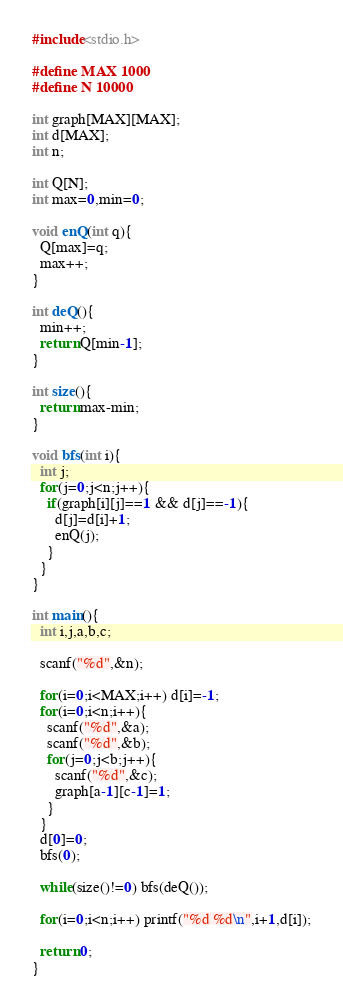<code> <loc_0><loc_0><loc_500><loc_500><_C_>#include<stdio.h>

#define MAX 1000
#define N 10000

int graph[MAX][MAX];
int d[MAX];
int n;

int Q[N];
int max=0,min=0;

void enQ(int q){
  Q[max]=q;
  max++;
}

int deQ(){
  min++;
  return Q[min-1];
}

int size(){
  return max-min;
}

void bfs(int i){
  int j;
  for(j=0;j<n;j++){
    if(graph[i][j]==1 && d[j]==-1){
      d[j]=d[i]+1;
      enQ(j);
    }
  }
}

int main(){
  int i,j,a,b,c;

  scanf("%d",&n);

  for(i=0;i<MAX;i++) d[i]=-1;
  for(i=0;i<n;i++){
    scanf("%d",&a);
    scanf("%d",&b);
    for(j=0;j<b;j++){
      scanf("%d",&c);
      graph[a-1][c-1]=1;
    }
  }
  d[0]=0;
  bfs(0);

  while(size()!=0) bfs(deQ());

  for(i=0;i<n;i++) printf("%d %d\n",i+1,d[i]);

  return 0;
}</code> 